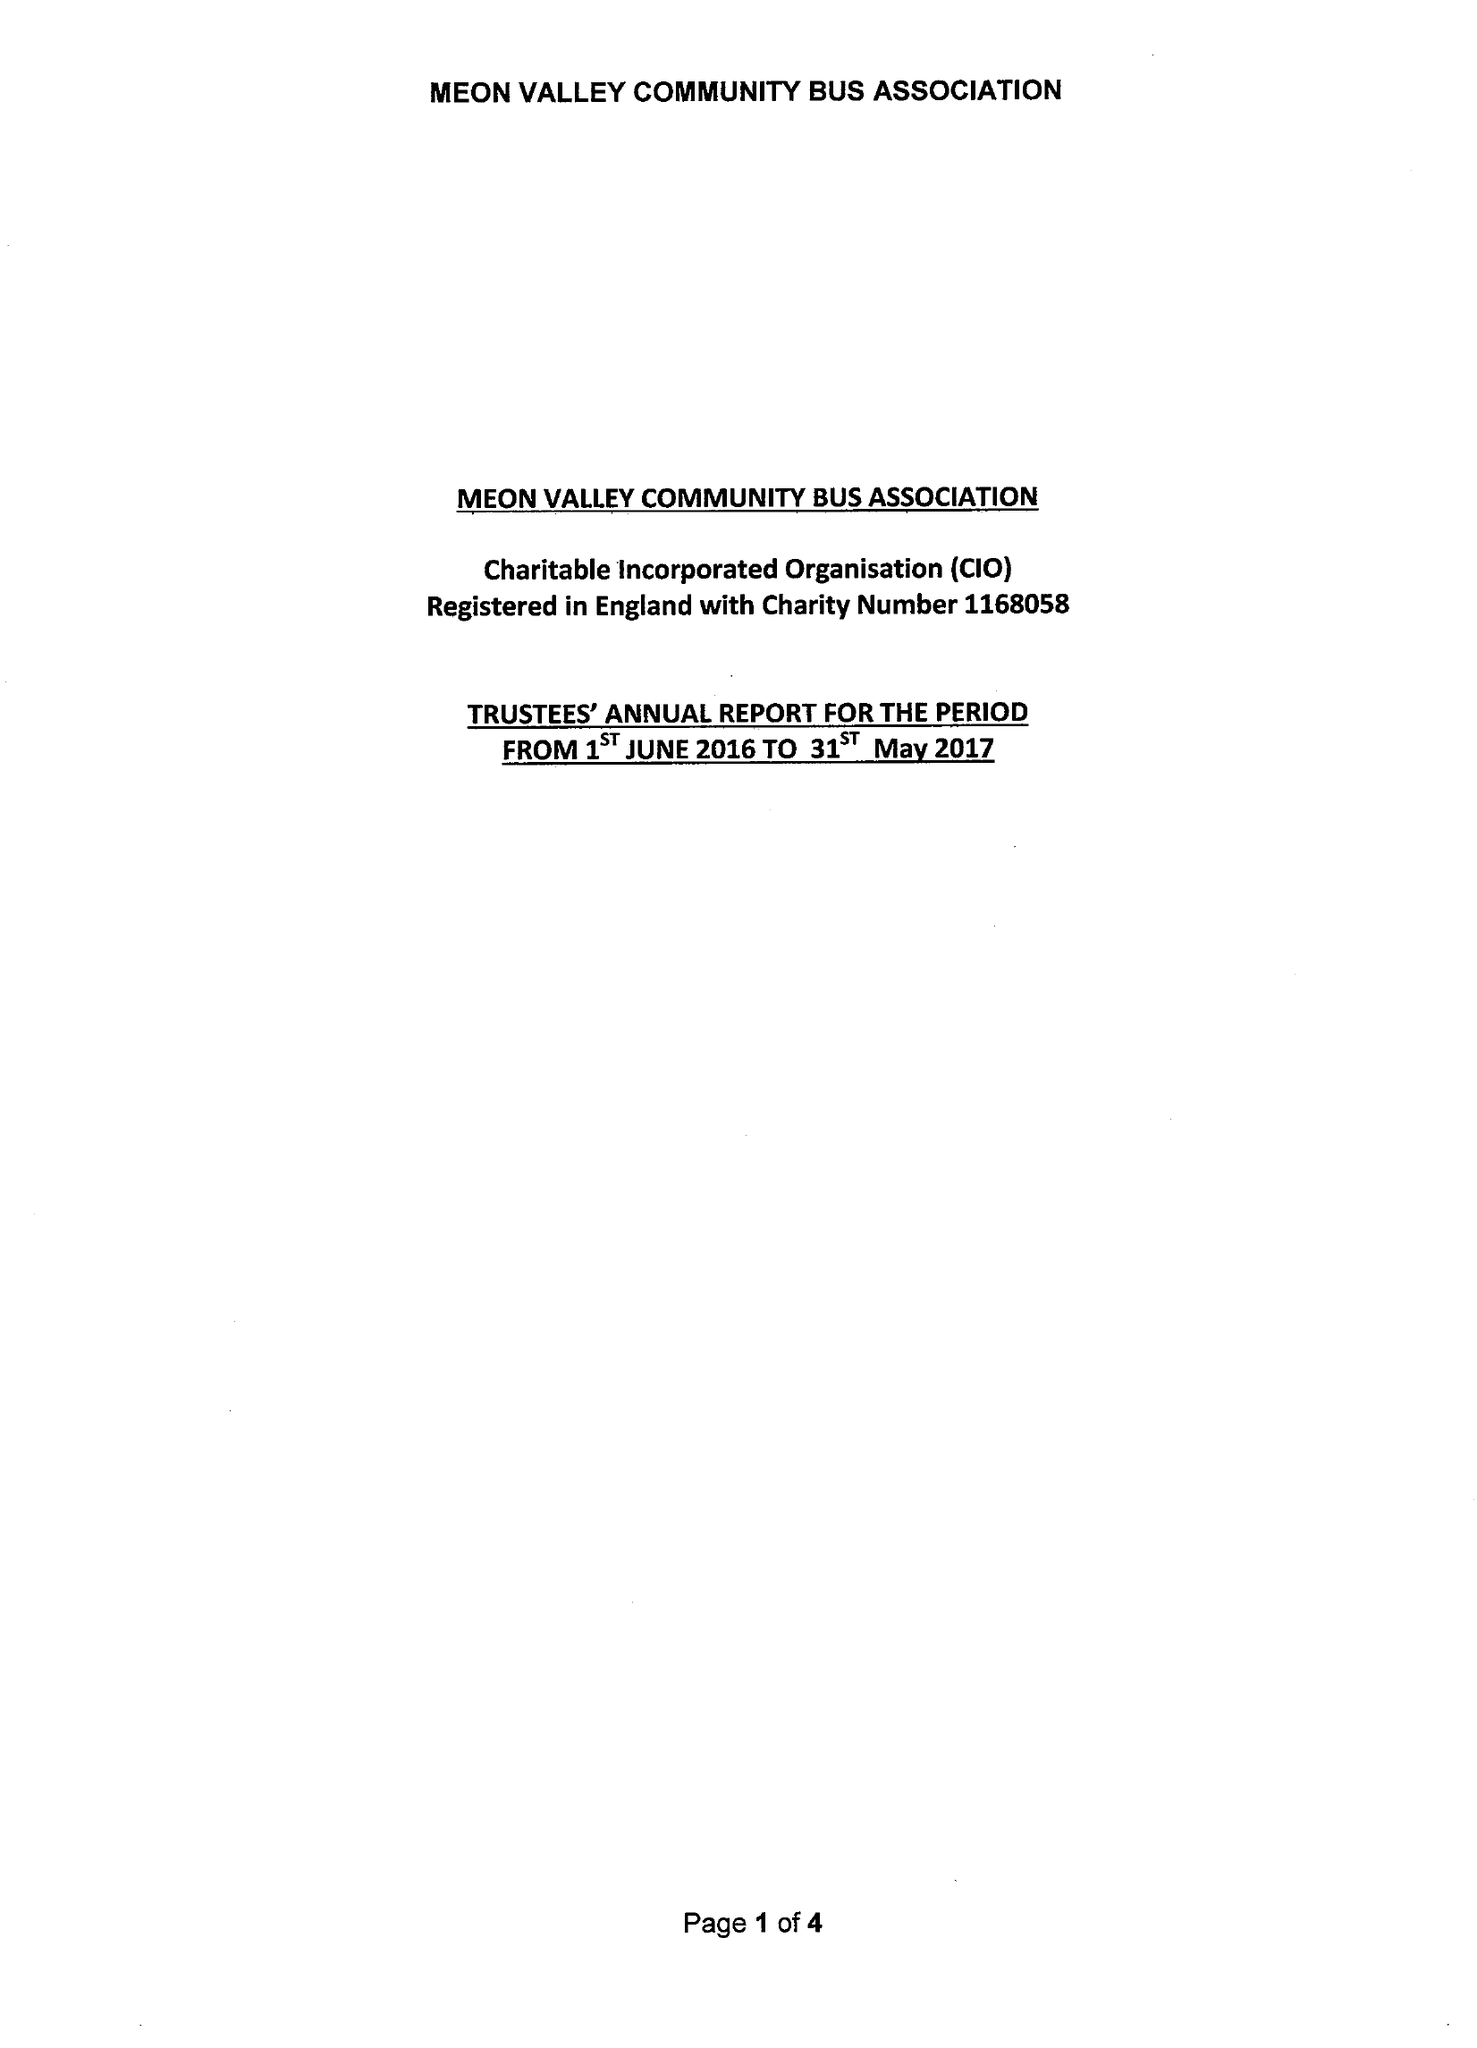What is the value for the income_annually_in_british_pounds?
Answer the question using a single word or phrase. 14516.00 